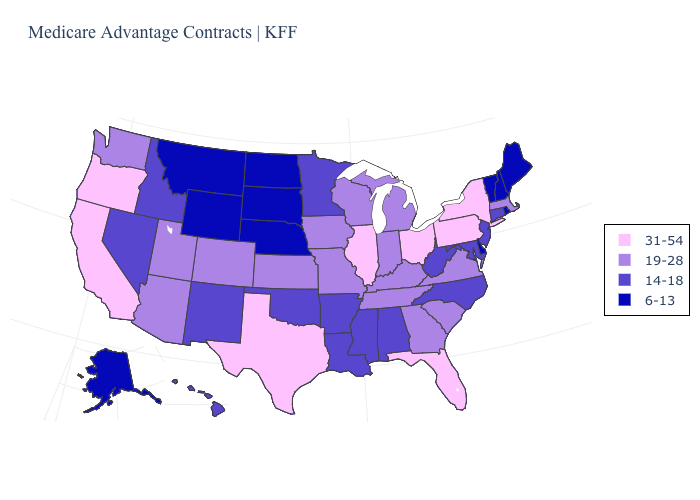Name the states that have a value in the range 14-18?
Answer briefly. Alabama, Arkansas, Connecticut, Hawaii, Idaho, Louisiana, Maryland, Minnesota, Mississippi, North Carolina, New Jersey, New Mexico, Nevada, Oklahoma, West Virginia. Name the states that have a value in the range 6-13?
Concise answer only. Alaska, Delaware, Maine, Montana, North Dakota, Nebraska, New Hampshire, Rhode Island, South Dakota, Vermont, Wyoming. Name the states that have a value in the range 19-28?
Concise answer only. Arizona, Colorado, Georgia, Iowa, Indiana, Kansas, Kentucky, Massachusetts, Michigan, Missouri, South Carolina, Tennessee, Utah, Virginia, Washington, Wisconsin. Does Missouri have a lower value than South Carolina?
Be succinct. No. What is the value of Tennessee?
Be succinct. 19-28. What is the value of Colorado?
Concise answer only. 19-28. Name the states that have a value in the range 19-28?
Answer briefly. Arizona, Colorado, Georgia, Iowa, Indiana, Kansas, Kentucky, Massachusetts, Michigan, Missouri, South Carolina, Tennessee, Utah, Virginia, Washington, Wisconsin. What is the highest value in the USA?
Be succinct. 31-54. Is the legend a continuous bar?
Short answer required. No. Name the states that have a value in the range 19-28?
Quick response, please. Arizona, Colorado, Georgia, Iowa, Indiana, Kansas, Kentucky, Massachusetts, Michigan, Missouri, South Carolina, Tennessee, Utah, Virginia, Washington, Wisconsin. Name the states that have a value in the range 19-28?
Write a very short answer. Arizona, Colorado, Georgia, Iowa, Indiana, Kansas, Kentucky, Massachusetts, Michigan, Missouri, South Carolina, Tennessee, Utah, Virginia, Washington, Wisconsin. What is the highest value in states that border Georgia?
Keep it brief. 31-54. Does Pennsylvania have the highest value in the Northeast?
Write a very short answer. Yes. Name the states that have a value in the range 31-54?
Short answer required. California, Florida, Illinois, New York, Ohio, Oregon, Pennsylvania, Texas. Name the states that have a value in the range 31-54?
Quick response, please. California, Florida, Illinois, New York, Ohio, Oregon, Pennsylvania, Texas. 